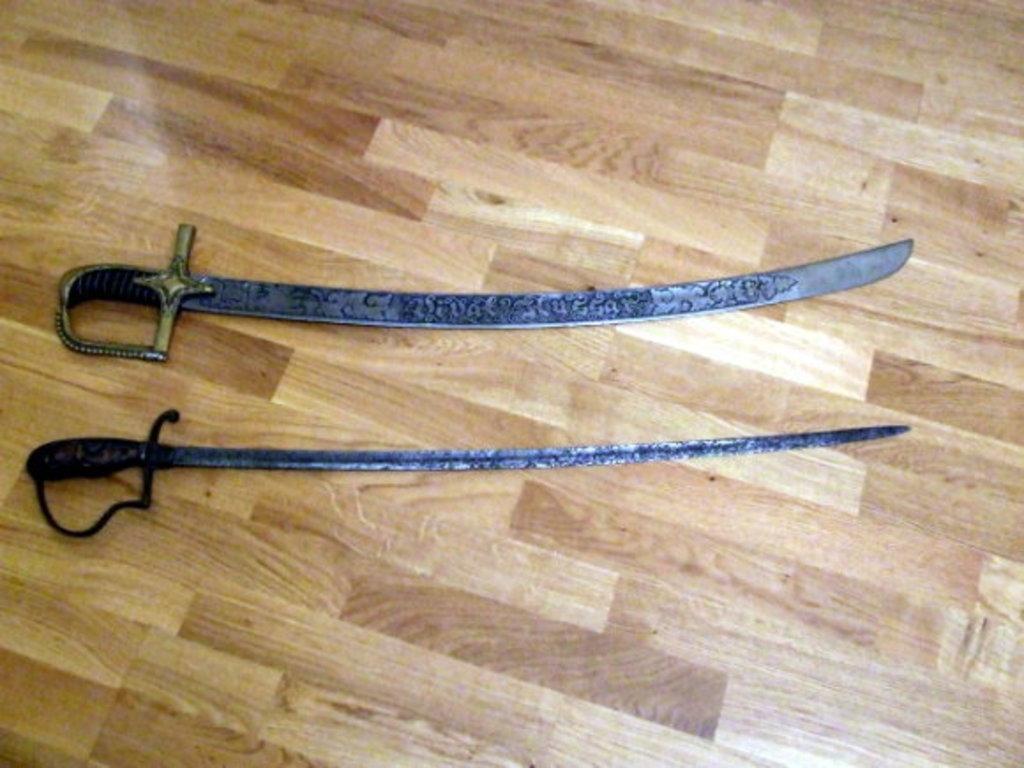Could you give a brief overview of what you see in this image? In this picture we can see two swords on the floor. 